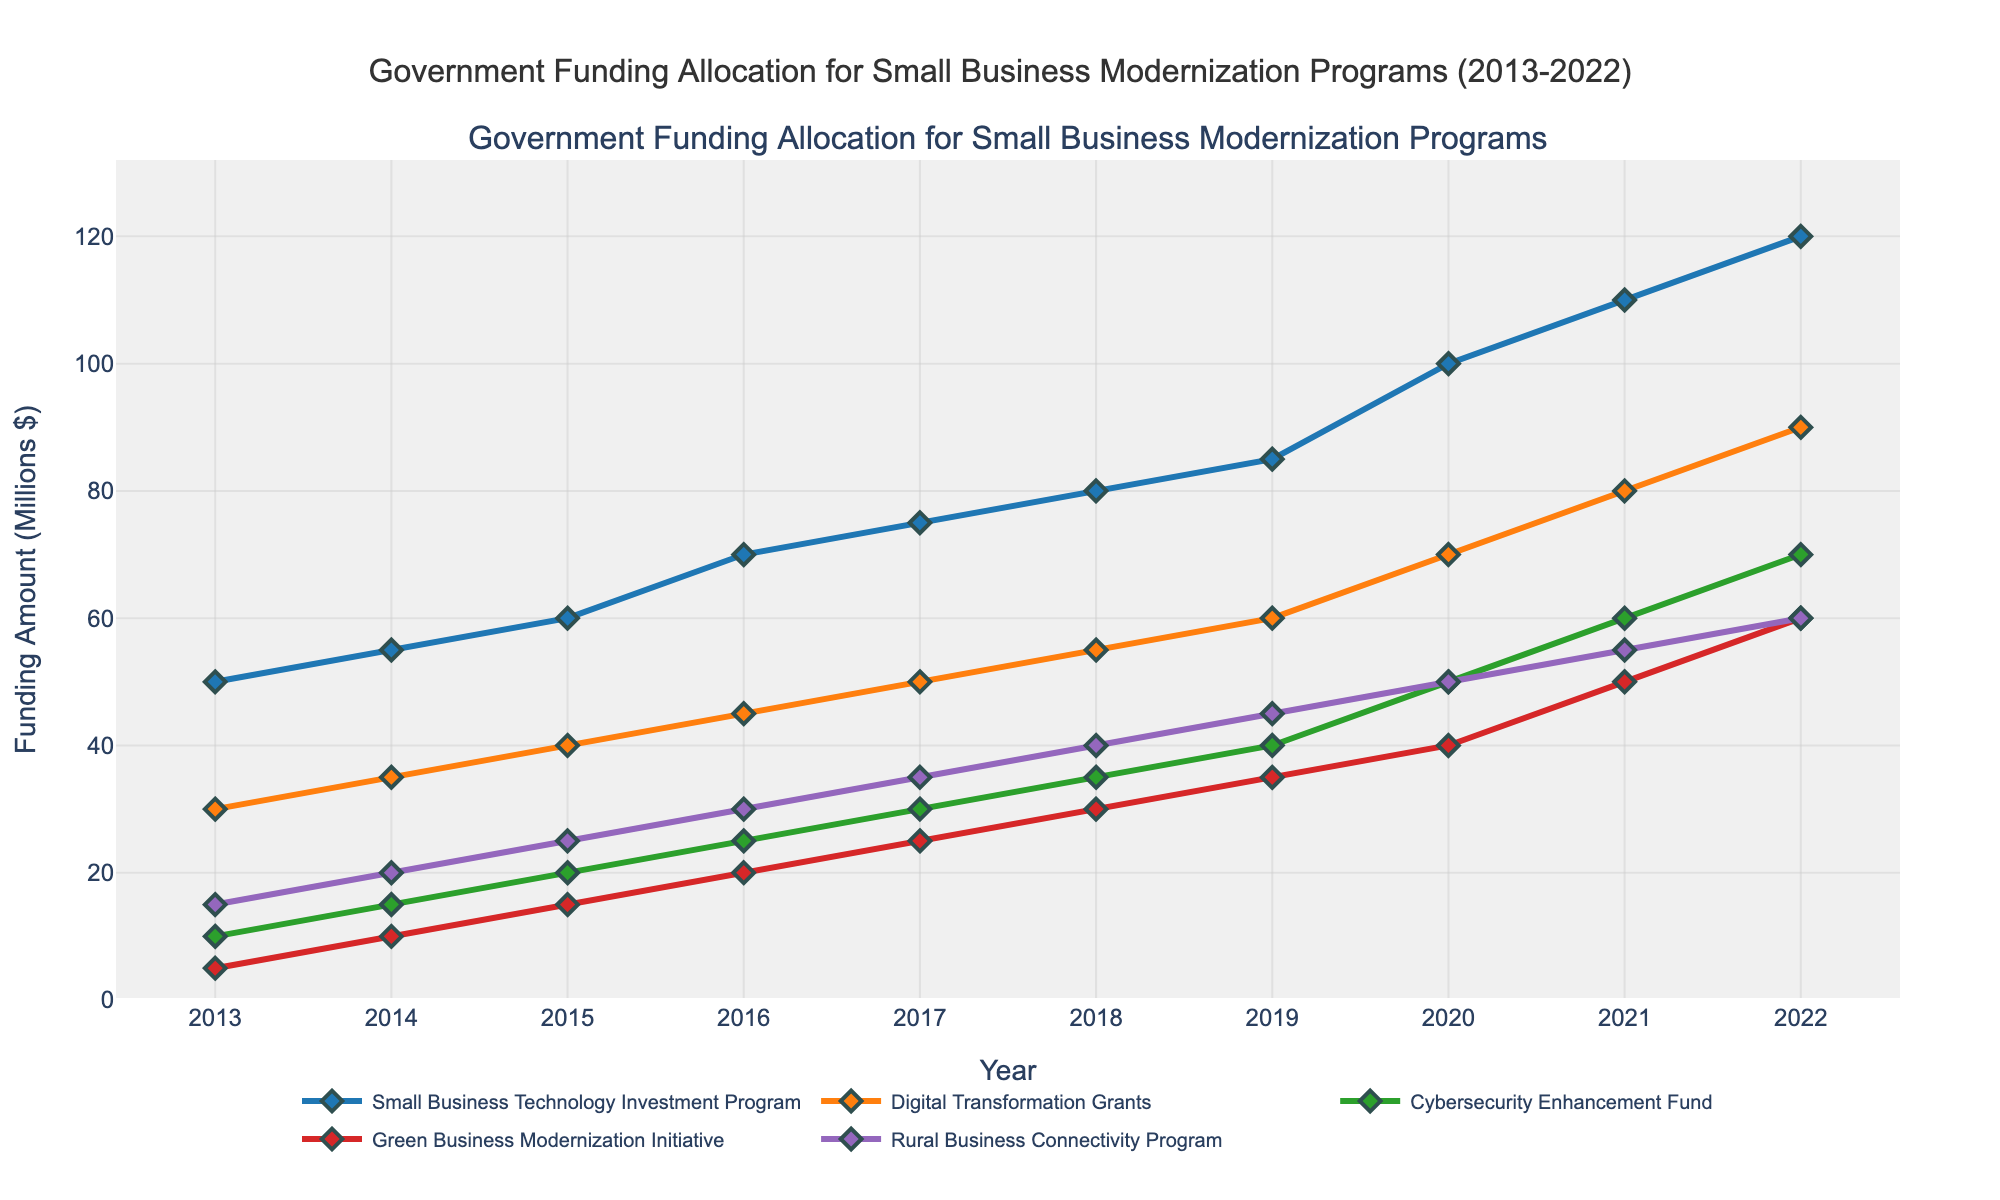What is the overall trend in funding for the Small Business Technology Investment Program from 2013 to 2022? The line representing the Small Business Technology Investment Program shows a consistent upward trend, starting at 50 million in 2013 and reaching 120 million by 2022. This indicates a steady increase in funding over the decade.
Answer: Steady increase Which program received the highest funding in 2022? In 2022, the highest funding is represented by the Small Business Technology Investment Program, which reached 120 million. This can be observed by comparing the end points of all lines.
Answer: Small Business Technology Investment Program What is the difference in funding between the Digital Transformation Grants and the Cybersecurity Enhancement Fund in 2020? In 2020, the Digital Transformation Grants received 70 million, and the Cybersecurity Enhancement Fund received 50 million. The difference in funding is calculated as 70 - 50 = 20 million.
Answer: 20 million How did the Green Business Modernization Initiative's funding change from 2015 to 2019? In 2015, the Green Business Modernization Initiative was funded with 15 million, and by 2019, it received 35 million. The increase in funding over these years is calculated as 35 - 15 = 20 million.
Answer: 20 million increase Which years saw an equal amount of funding for both the Rural Business Connectivity Program and Green Business Modernization Initiative? The lines representing the Rural Business Connectivity Program and Green Business Modernization Initiative intersect in 2022, where both received 60 million in funding.
Answer: 2022 What's the average funding of the Cybersecurity Enhancement Fund across the entire period? Add the annual amounts from 2013 to 2022 (10 + 15 + 20 + 25 + 30 + 35 + 40 + 50 + 60 + 70 = 355) and divide by the 10 years. The average funding is 355 / 10 = 35.5 million.
Answer: 35.5 million Between 2013 and 2022, which program experienced the largest growth in its funding amount? Compare the funding increases of all programs: Small Business Technology Investment Program (120 - 50 = 70), Digital Transformation Grants (90 - 30 = 60), Cybersecurity Enhancement Fund (70 - 10 = 60), Green Business Modernization Initiative (60 - 5 = 55), and Rural Business Connectivity Program (60 - 15 = 45). The largest growth is observed in the Small Business Technology Investment Program with 70 million.
Answer: Small Business Technology Investment Program Is there any year where the Digital Transformation Grants funding surpasses the Small Business Technology Investment Program, and if so, which year is it? By visually comparing the two lines, there is no year where the line for Digital Transformation Grants is above the line for the Small Business Technology Investment Program. Thus, no year meets this condition.
Answer: None 